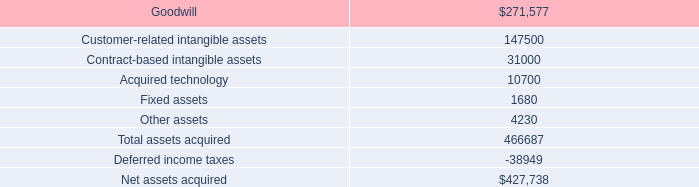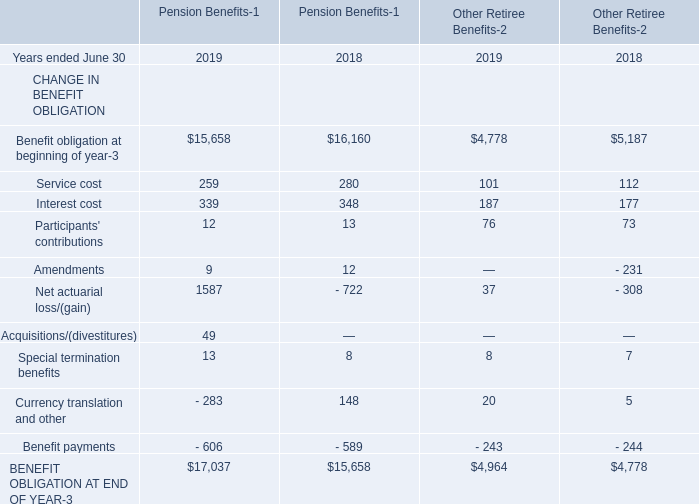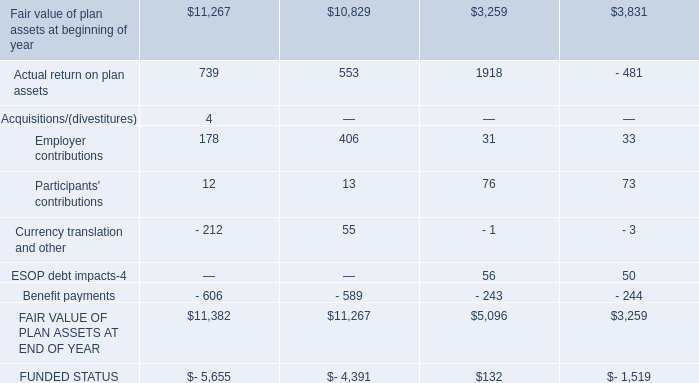What is the total amount of FAIR VALUE OF PLAN ASSETS AT END OF YEAR, and BENEFIT OBLIGATION AT END OF YEAR of Pension Benefits 2018 ? 
Computations: (5096.0 + 15658.0)
Answer: 20754.0. 